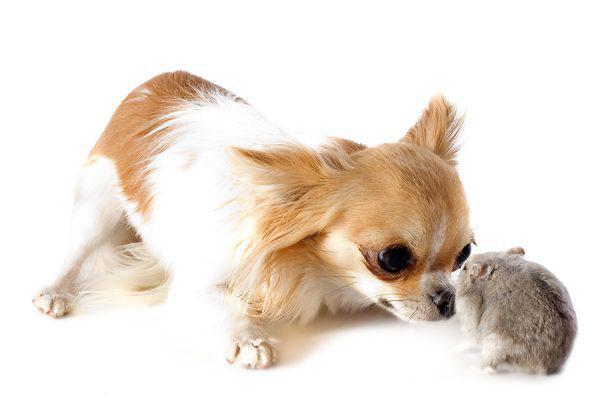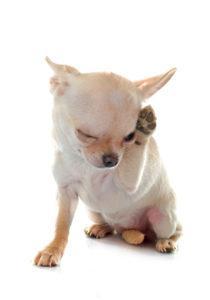The first image is the image on the left, the second image is the image on the right. Analyze the images presented: Is the assertion "The left image contains one dog that has a fork in its mouth." valid? Answer yes or no. No. The first image is the image on the left, the second image is the image on the right. Considering the images on both sides, is "The left image shows a chihuahua with a fork handle in its mouth sitting behind food." valid? Answer yes or no. No. 